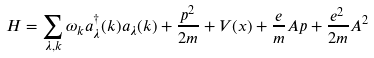<formula> <loc_0><loc_0><loc_500><loc_500>H = \sum _ { \lambda , { k } } \omega _ { k } a ^ { \dagger } _ { \lambda } ( { k } ) a _ { \lambda } ( { k } ) + \frac { { p } ^ { 2 } } { 2 m } + V ( { x } ) + \frac { e } { m } { A } { p } + \frac { e ^ { 2 } } { 2 m } { A } ^ { 2 }</formula> 